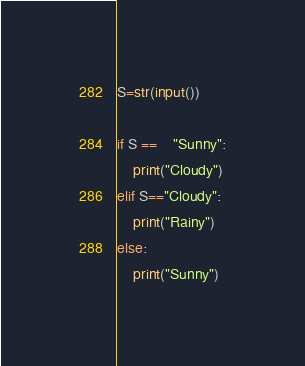<code> <loc_0><loc_0><loc_500><loc_500><_Python_>S=str(input())

if S ==	"Sunny":
    print("Cloudy")
elif S=="Cloudy":
    print("Rainy")
else:
    print("Sunny")
</code> 